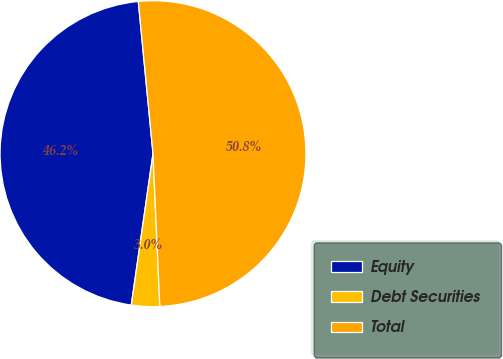<chart> <loc_0><loc_0><loc_500><loc_500><pie_chart><fcel>Equity<fcel>Debt Securities<fcel>Total<nl><fcel>46.2%<fcel>2.98%<fcel>50.82%<nl></chart> 